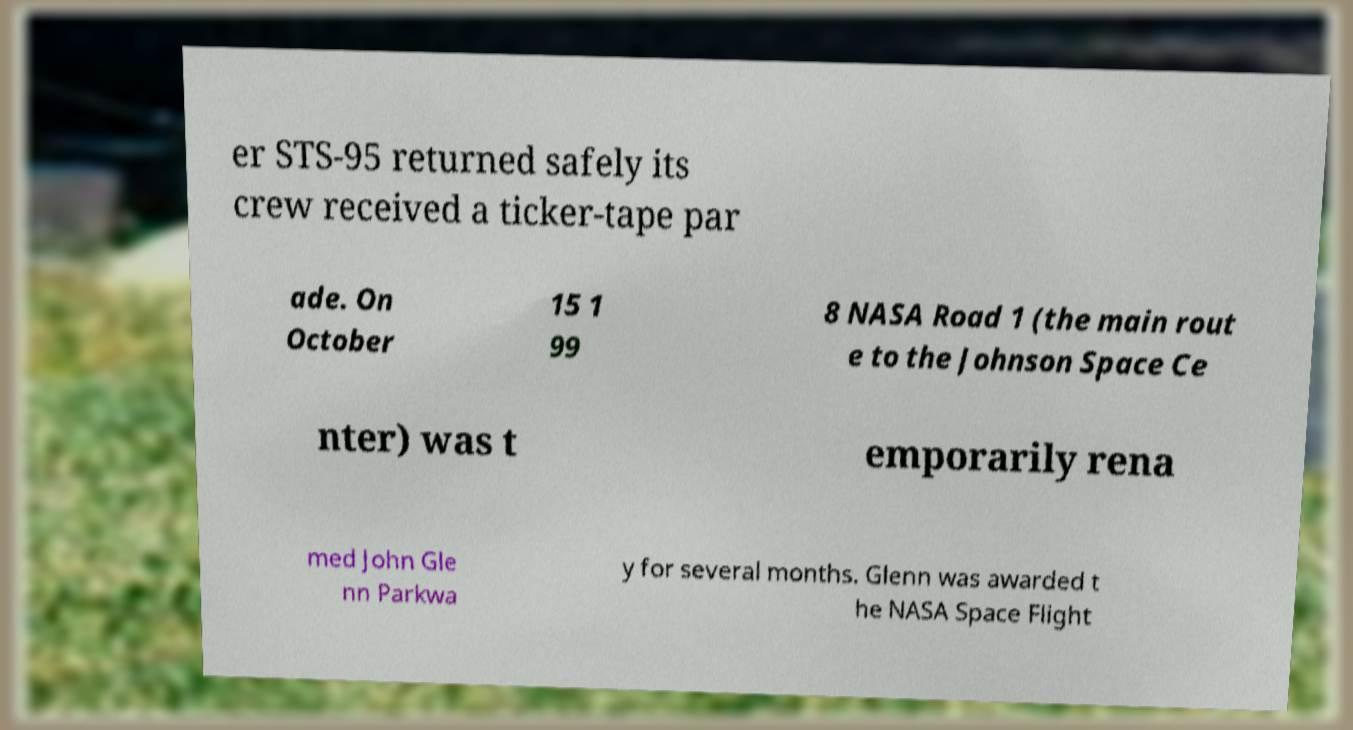Could you extract and type out the text from this image? er STS-95 returned safely its crew received a ticker-tape par ade. On October 15 1 99 8 NASA Road 1 (the main rout e to the Johnson Space Ce nter) was t emporarily rena med John Gle nn Parkwa y for several months. Glenn was awarded t he NASA Space Flight 